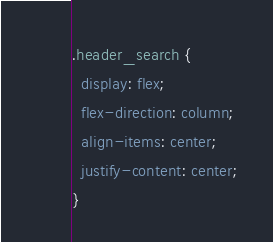<code> <loc_0><loc_0><loc_500><loc_500><_CSS_>.header_search {
  display: flex;
  flex-direction: column;
  align-items: center;
  justify-content: center;
}
</code> 